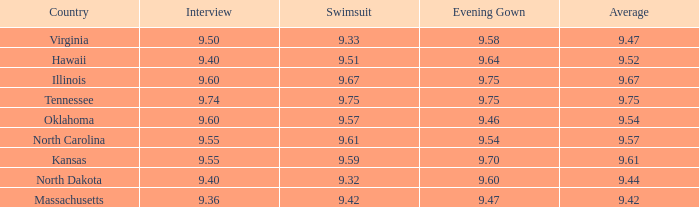What was the average for the country with the swimsuit score of 9.57? 9.54. 